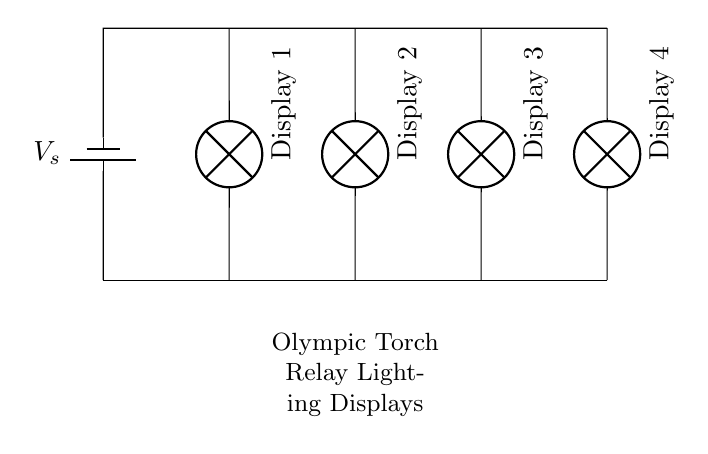what type of circuit is shown? The circuit diagram depicts a parallel circuit arrangement, where multiple lamps are connected alongside each other across the same voltage source.
Answer: parallel circuit how many display lamps are there? The diagram shows four display lamps connected in the circuit, indicating the number of visual displays that will light up.
Answer: four what is the purpose of the battery in this circuit? The battery serves as the voltage source, providing the electrical potential needed for the lamps to illuminate.
Answer: provide voltage if one lamp fails, what happens to the others? In a parallel circuit, if one lamp fails, the remaining lamps continue to function because they are connected independently to the voltage source.
Answer: stay on how are the display lamps configured in relation to the voltage source? All the display lamps are connected in parallel to the voltage source, meaning each lamp is wired directly to the source allowing for full voltage across each lamp.
Answer: in parallel what would be the effect of adding another lamp? Adding another lamp in parallel would increase the overall current drawn from the battery without affecting the brightness of the existing lamps.
Answer: increase current what is the main advantage of using a parallel arrangement in lighting displays? The main advantage is that it allows each lighting display to operate independently, ensuring that failure of one does not affect the others.
Answer: independent operation 